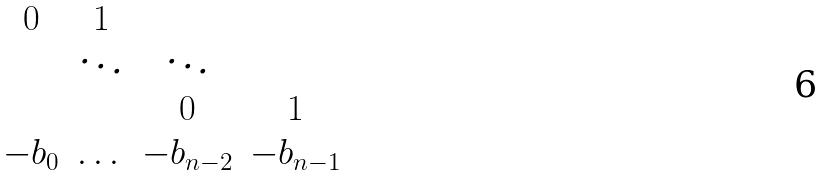Convert formula to latex. <formula><loc_0><loc_0><loc_500><loc_500>\begin{matrix} 0 & 1 & & \\ & \ddots & \ddots & \\ & & 0 & 1 \\ - b _ { 0 } & \dots & - b _ { n - 2 } & - b _ { n - 1 } \end{matrix}</formula> 